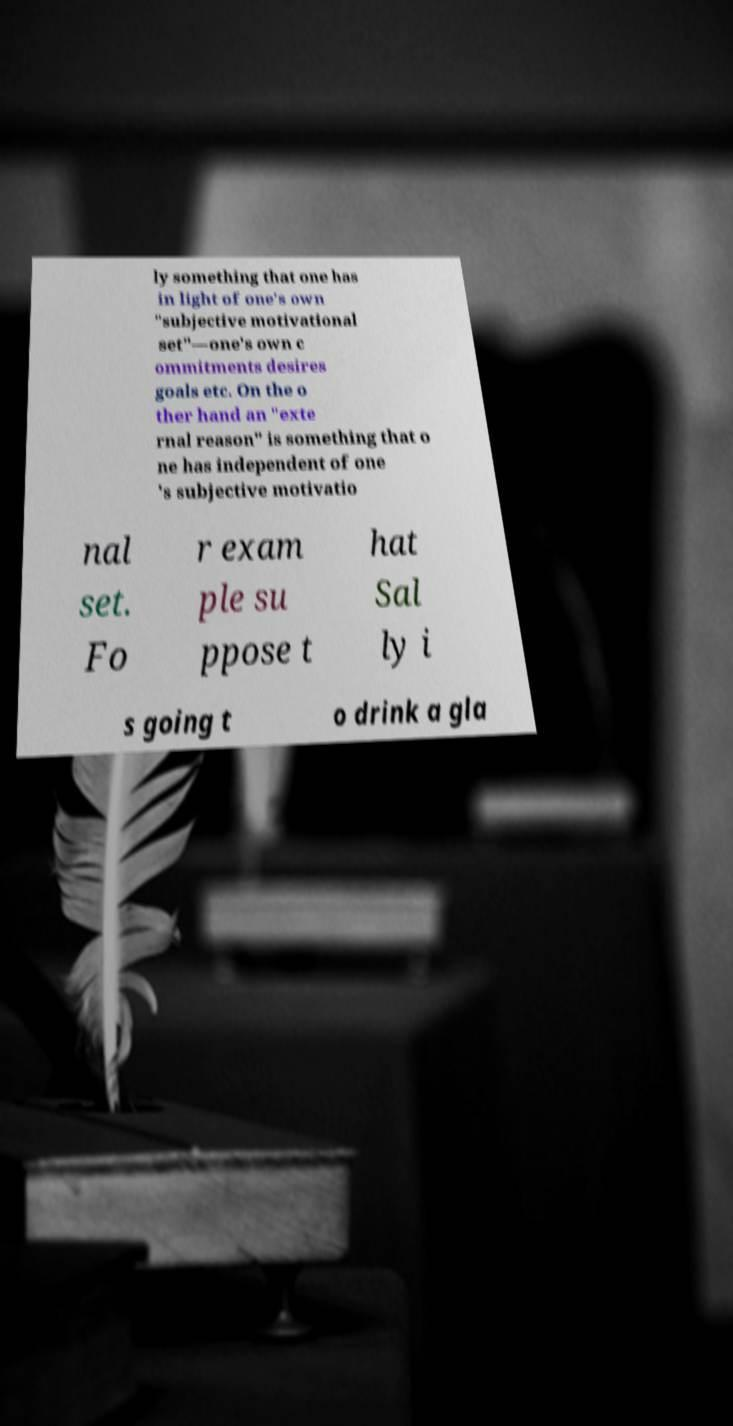Please identify and transcribe the text found in this image. ly something that one has in light of one's own "subjective motivational set"—one's own c ommitments desires goals etc. On the o ther hand an "exte rnal reason" is something that o ne has independent of one 's subjective motivatio nal set. Fo r exam ple su ppose t hat Sal ly i s going t o drink a gla 